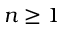<formula> <loc_0><loc_0><loc_500><loc_500>n \geq 1</formula> 